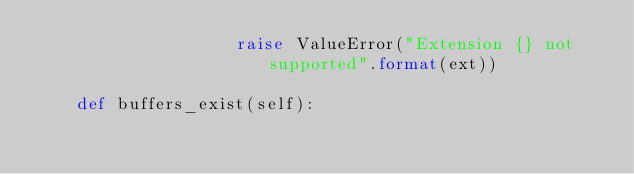Convert code to text. <code><loc_0><loc_0><loc_500><loc_500><_Python_>                    raise ValueError("Extension {} not supported".format(ext))

    def buffers_exist(self):</code> 